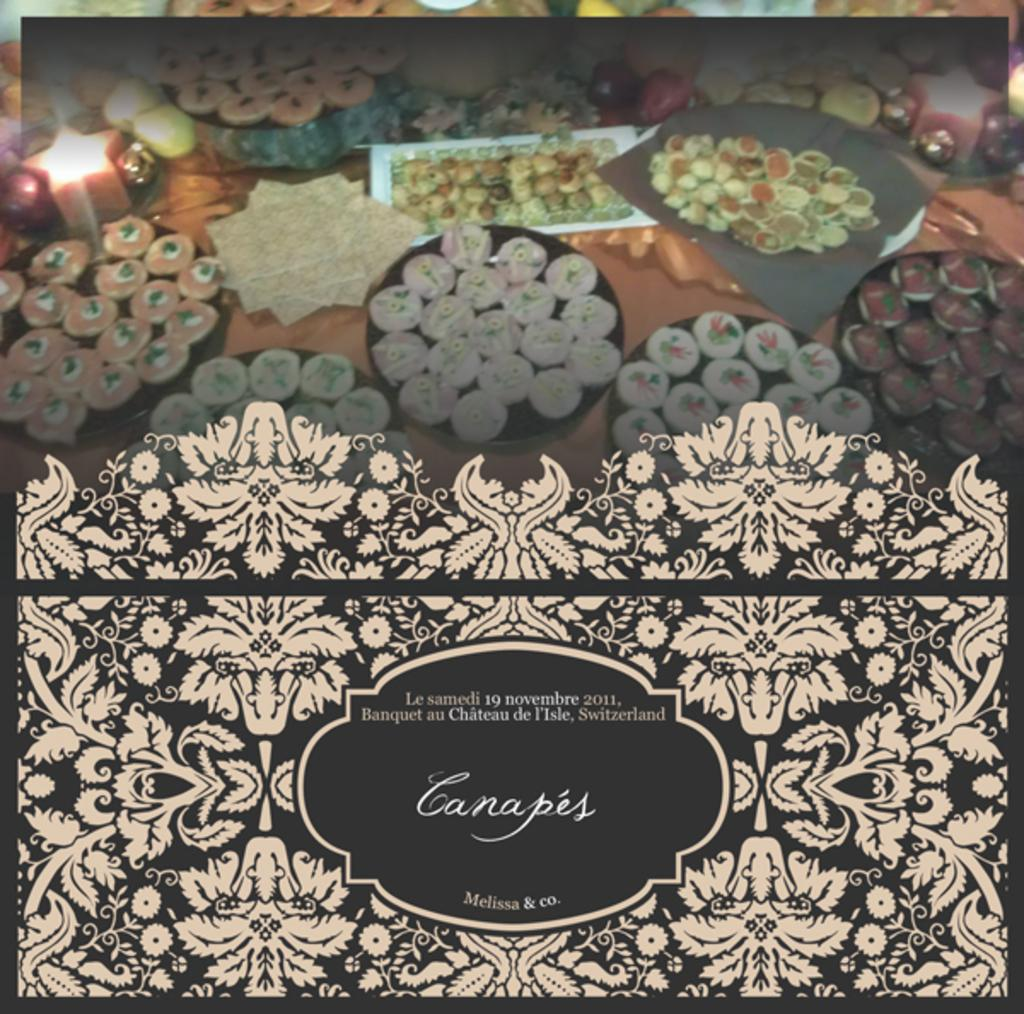What is present in the image that features images? There is a poster in the image that contains pictures. What type of images can be seen on the poster? The poster contains pictures of food items. Is there any text on the poster? Yes, text is written on the poster. Can you tell me how many people are swimming in the image? There is no swimming or people swimming present in the image; it features a poster with pictures of food items and text. 